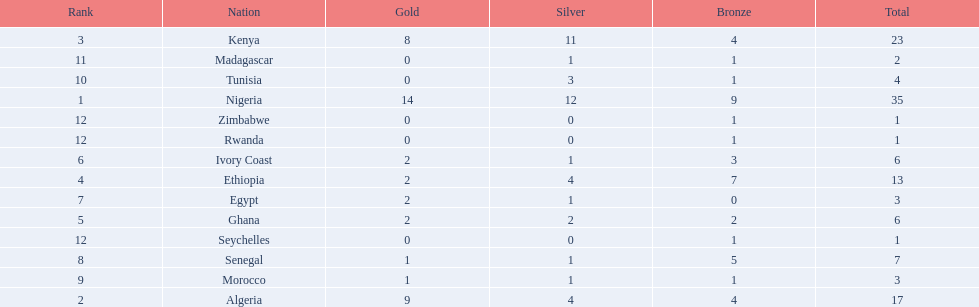What are all the nations? Nigeria, Algeria, Kenya, Ethiopia, Ghana, Ivory Coast, Egypt, Senegal, Morocco, Tunisia, Madagascar, Rwanda, Zimbabwe, Seychelles. How many bronze medals did they win? 9, 4, 4, 7, 2, 3, 0, 5, 1, 1, 1, 1, 1, 1. And which nation did not win one? Egypt. 